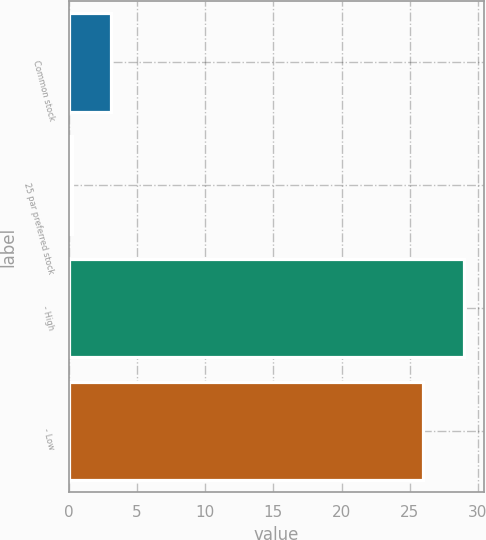Convert chart. <chart><loc_0><loc_0><loc_500><loc_500><bar_chart><fcel>Common stock<fcel>25 par preferred stock<fcel>- High<fcel>- Low<nl><fcel>3.12<fcel>0.25<fcel>29<fcel>26<nl></chart> 